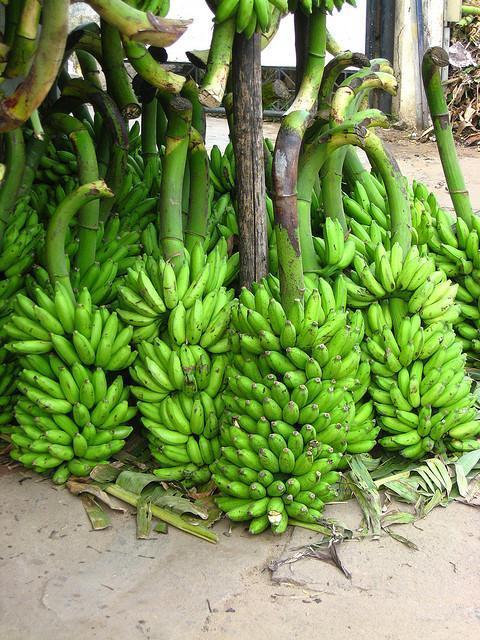How many bananas are in the picture?
Give a very brief answer. 6. How many people have a blue umbrella?
Give a very brief answer. 0. 